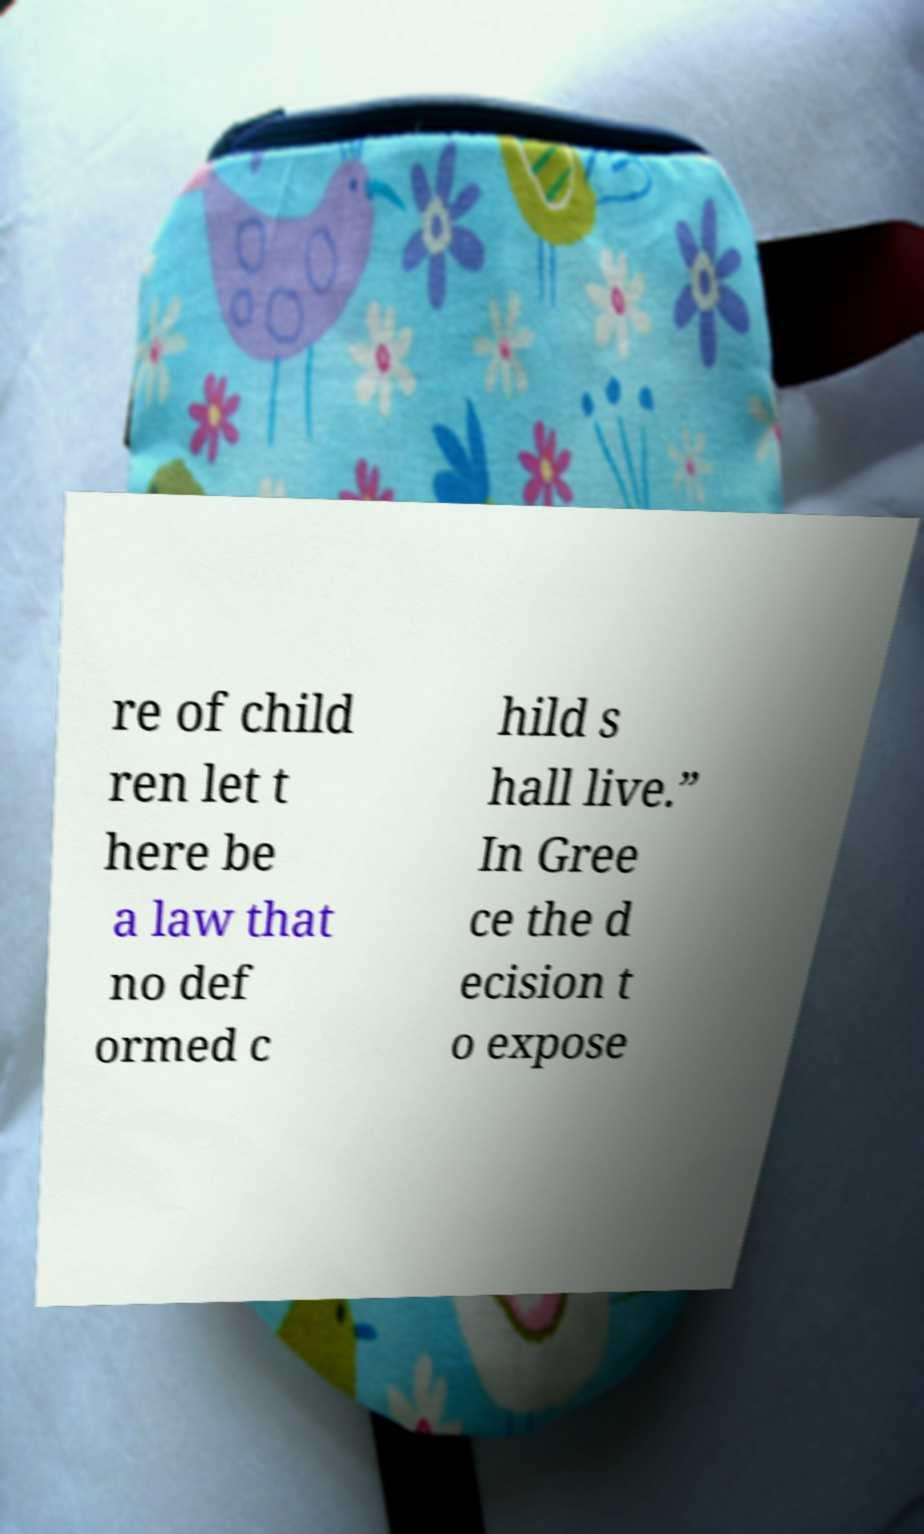Please identify and transcribe the text found in this image. re of child ren let t here be a law that no def ormed c hild s hall live.” In Gree ce the d ecision t o expose 